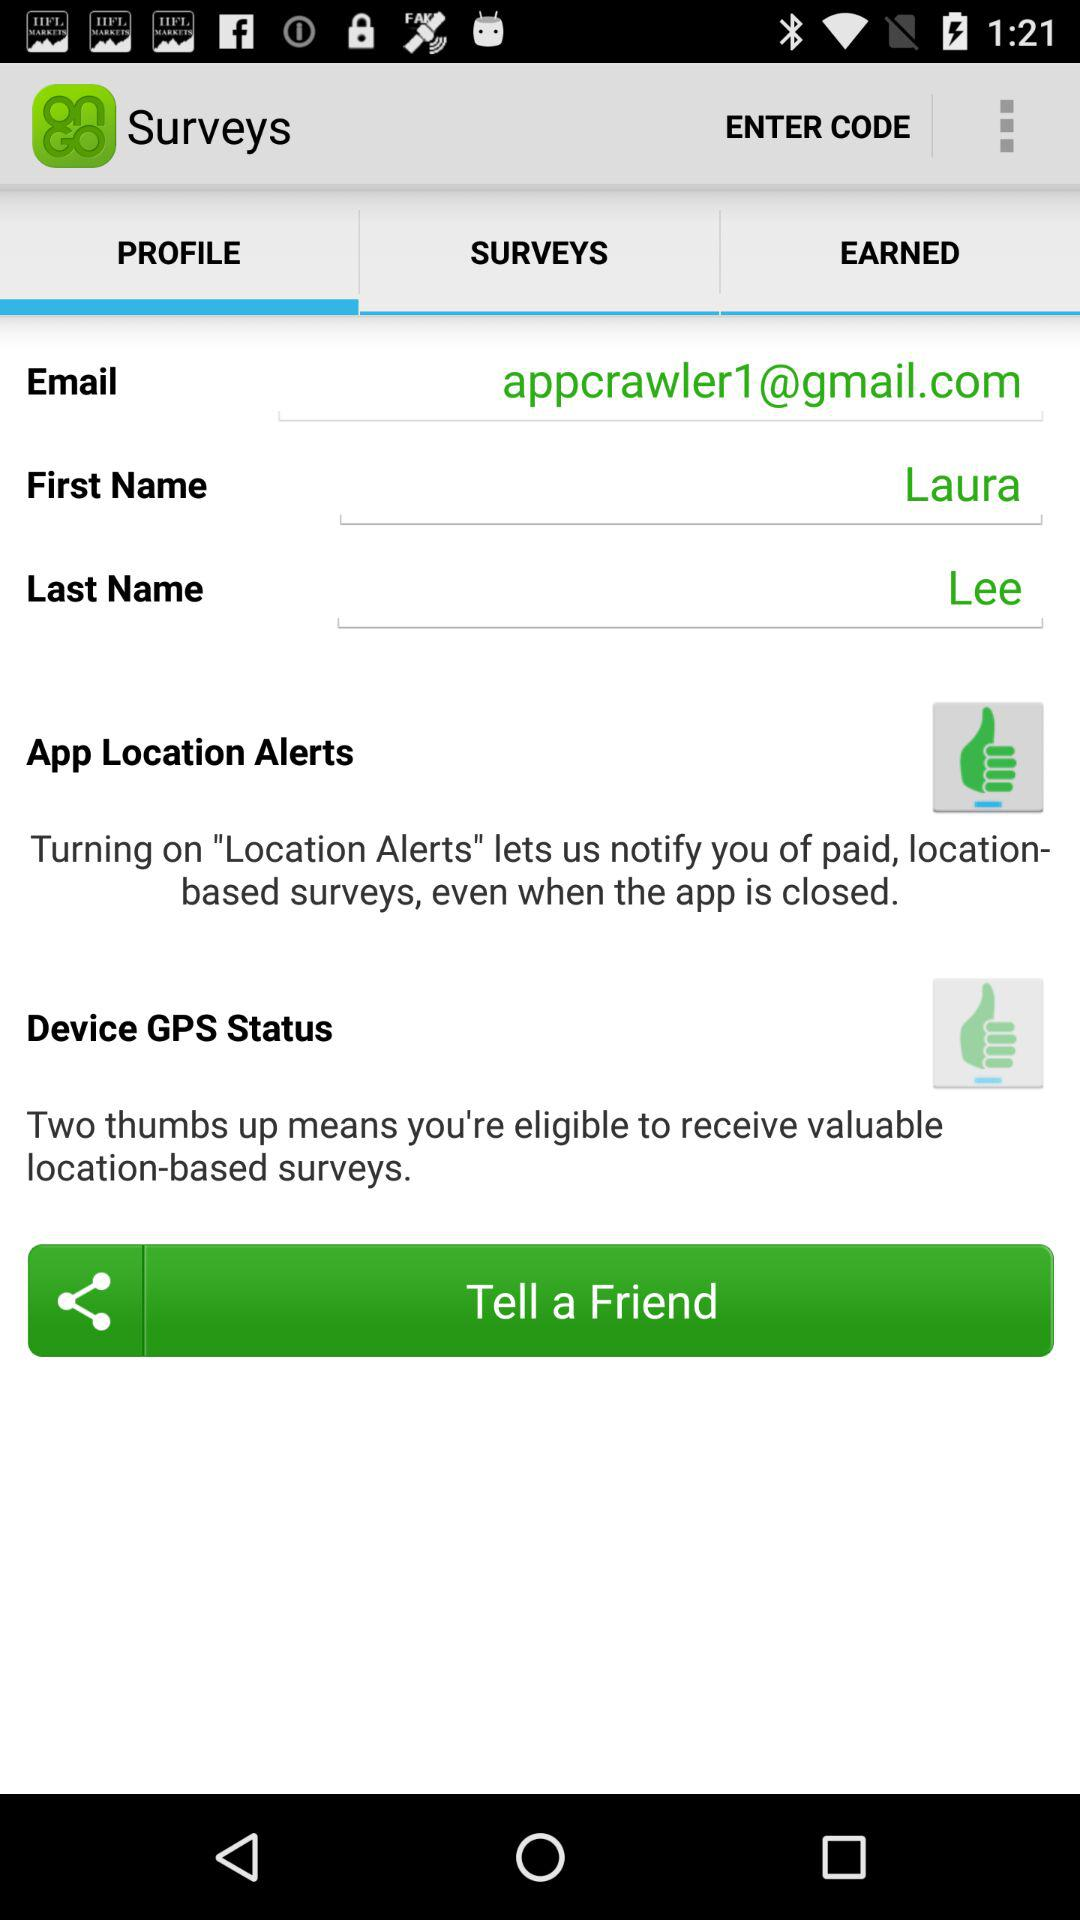What is the status of the "App Location Alerts"? The status is "on". 